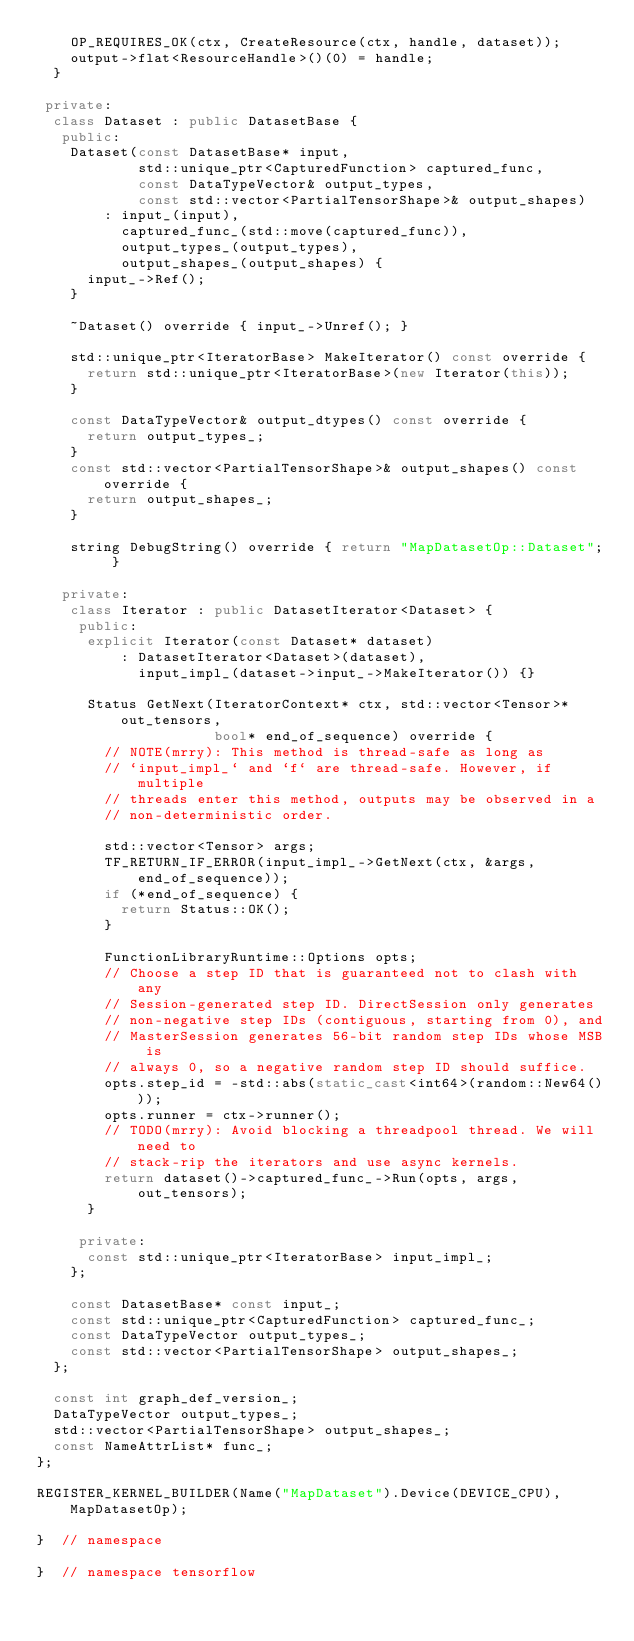<code> <loc_0><loc_0><loc_500><loc_500><_C++_>    OP_REQUIRES_OK(ctx, CreateResource(ctx, handle, dataset));
    output->flat<ResourceHandle>()(0) = handle;
  }

 private:
  class Dataset : public DatasetBase {
   public:
    Dataset(const DatasetBase* input,
            std::unique_ptr<CapturedFunction> captured_func,
            const DataTypeVector& output_types,
            const std::vector<PartialTensorShape>& output_shapes)
        : input_(input),
          captured_func_(std::move(captured_func)),
          output_types_(output_types),
          output_shapes_(output_shapes) {
      input_->Ref();
    }

    ~Dataset() override { input_->Unref(); }

    std::unique_ptr<IteratorBase> MakeIterator() const override {
      return std::unique_ptr<IteratorBase>(new Iterator(this));
    }

    const DataTypeVector& output_dtypes() const override {
      return output_types_;
    }
    const std::vector<PartialTensorShape>& output_shapes() const override {
      return output_shapes_;
    }

    string DebugString() override { return "MapDatasetOp::Dataset"; }

   private:
    class Iterator : public DatasetIterator<Dataset> {
     public:
      explicit Iterator(const Dataset* dataset)
          : DatasetIterator<Dataset>(dataset),
            input_impl_(dataset->input_->MakeIterator()) {}

      Status GetNext(IteratorContext* ctx, std::vector<Tensor>* out_tensors,
                     bool* end_of_sequence) override {
        // NOTE(mrry): This method is thread-safe as long as
        // `input_impl_` and `f` are thread-safe. However, if multiple
        // threads enter this method, outputs may be observed in a
        // non-deterministic order.

        std::vector<Tensor> args;
        TF_RETURN_IF_ERROR(input_impl_->GetNext(ctx, &args, end_of_sequence));
        if (*end_of_sequence) {
          return Status::OK();
        }

        FunctionLibraryRuntime::Options opts;
        // Choose a step ID that is guaranteed not to clash with any
        // Session-generated step ID. DirectSession only generates
        // non-negative step IDs (contiguous, starting from 0), and
        // MasterSession generates 56-bit random step IDs whose MSB is
        // always 0, so a negative random step ID should suffice.
        opts.step_id = -std::abs(static_cast<int64>(random::New64()));
        opts.runner = ctx->runner();
        // TODO(mrry): Avoid blocking a threadpool thread. We will need to
        // stack-rip the iterators and use async kernels.
        return dataset()->captured_func_->Run(opts, args, out_tensors);
      }

     private:
      const std::unique_ptr<IteratorBase> input_impl_;
    };

    const DatasetBase* const input_;
    const std::unique_ptr<CapturedFunction> captured_func_;
    const DataTypeVector output_types_;
    const std::vector<PartialTensorShape> output_shapes_;
  };

  const int graph_def_version_;
  DataTypeVector output_types_;
  std::vector<PartialTensorShape> output_shapes_;
  const NameAttrList* func_;
};

REGISTER_KERNEL_BUILDER(Name("MapDataset").Device(DEVICE_CPU), MapDatasetOp);

}  // namespace

}  // namespace tensorflow
</code> 